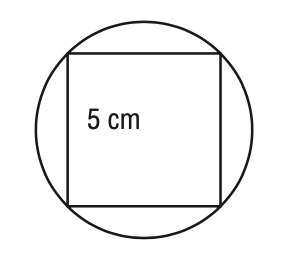Answer the mathemtical geometry problem and directly provide the correct option letter.
Question: A square with 5 - centimeter sides is inscribed in a circle. What is the circumference of the circle? Round your answer to the nearest tenth of a centimeter.
Choices: A: 11.1 B: 22.2 C: 44.4 D: 88.9 B 